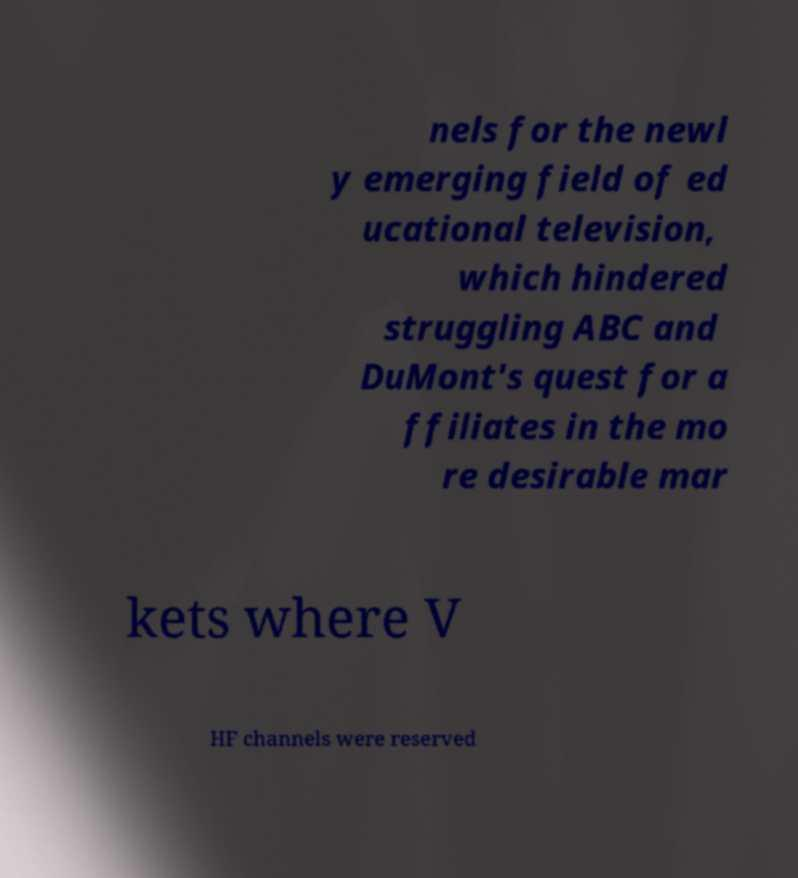Can you accurately transcribe the text from the provided image for me? nels for the newl y emerging field of ed ucational television, which hindered struggling ABC and DuMont's quest for a ffiliates in the mo re desirable mar kets where V HF channels were reserved 